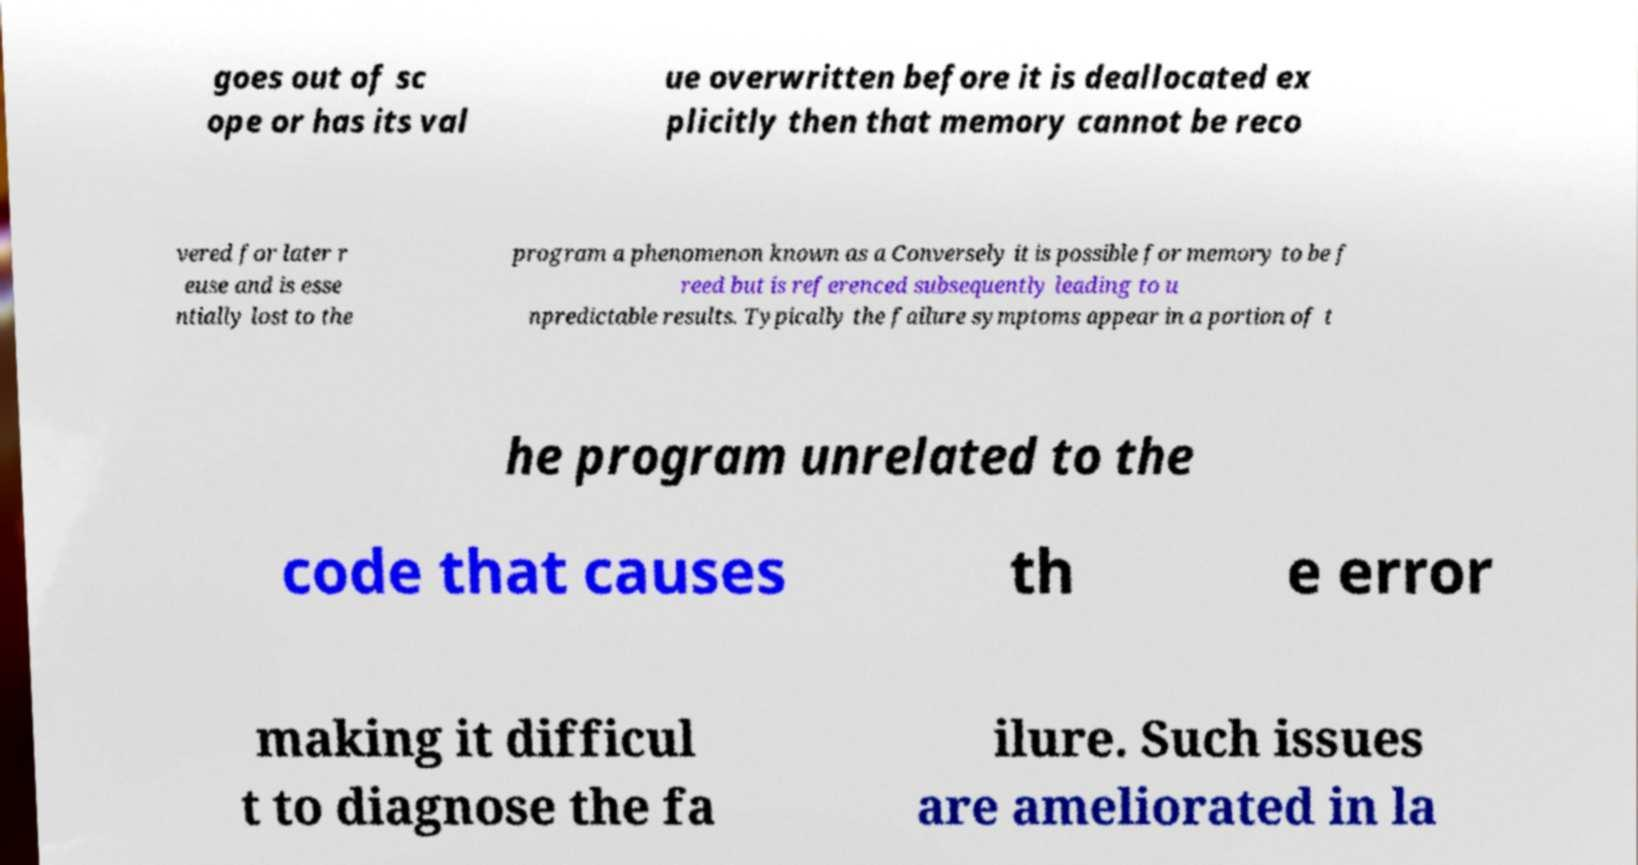I need the written content from this picture converted into text. Can you do that? goes out of sc ope or has its val ue overwritten before it is deallocated ex plicitly then that memory cannot be reco vered for later r euse and is esse ntially lost to the program a phenomenon known as a Conversely it is possible for memory to be f reed but is referenced subsequently leading to u npredictable results. Typically the failure symptoms appear in a portion of t he program unrelated to the code that causes th e error making it difficul t to diagnose the fa ilure. Such issues are ameliorated in la 